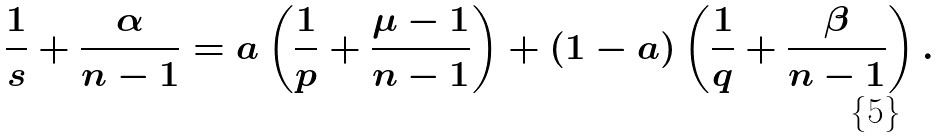<formula> <loc_0><loc_0><loc_500><loc_500>\frac { 1 } { s } + \frac { \alpha } { n - 1 } = a \left ( \frac { 1 } { p } + \frac { \mu - 1 } { n - 1 } \right ) + ( 1 - a ) \left ( \frac { 1 } { q } + \frac { \beta } { n - 1 } \right ) .</formula> 